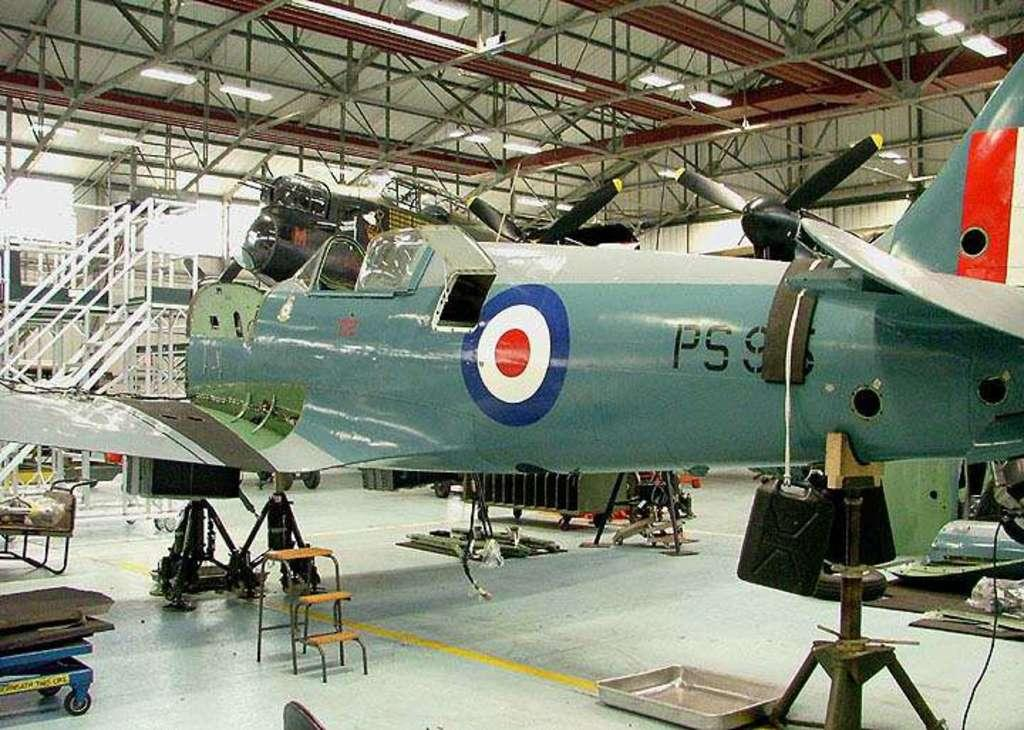What is the main subject of the image? The main subject of the image is an airplane on a stand. What can be seen in the background of the image? In the background of the image, there is truss, lights, and other objects visible. Can you describe the truss in the background? The truss in the background is a framework of connected elements, typically used to support structures. What type of vegetable is being used as a prop for the airplane in the image? There is no vegetable present in the image, and the airplane is not supported by any prop. 